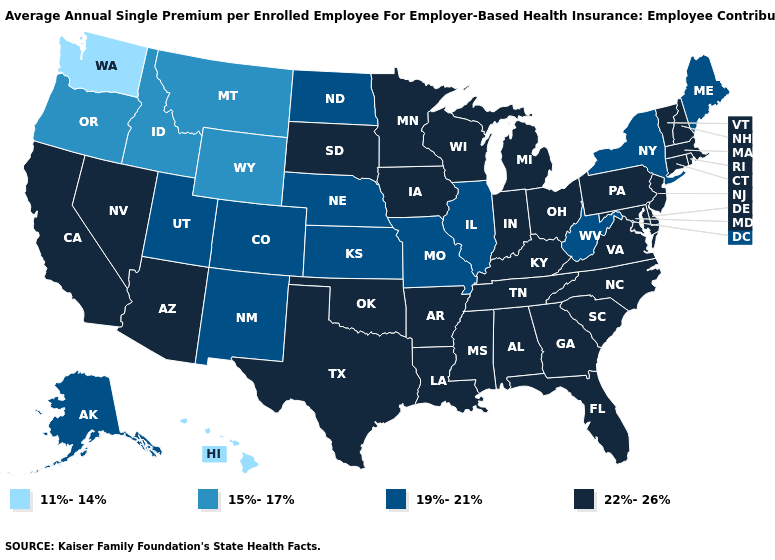What is the highest value in the USA?
Short answer required. 22%-26%. Name the states that have a value in the range 22%-26%?
Write a very short answer. Alabama, Arizona, Arkansas, California, Connecticut, Delaware, Florida, Georgia, Indiana, Iowa, Kentucky, Louisiana, Maryland, Massachusetts, Michigan, Minnesota, Mississippi, Nevada, New Hampshire, New Jersey, North Carolina, Ohio, Oklahoma, Pennsylvania, Rhode Island, South Carolina, South Dakota, Tennessee, Texas, Vermont, Virginia, Wisconsin. What is the value of New Hampshire?
Short answer required. 22%-26%. What is the lowest value in the USA?
Write a very short answer. 11%-14%. What is the highest value in states that border Washington?
Write a very short answer. 15%-17%. Name the states that have a value in the range 22%-26%?
Concise answer only. Alabama, Arizona, Arkansas, California, Connecticut, Delaware, Florida, Georgia, Indiana, Iowa, Kentucky, Louisiana, Maryland, Massachusetts, Michigan, Minnesota, Mississippi, Nevada, New Hampshire, New Jersey, North Carolina, Ohio, Oklahoma, Pennsylvania, Rhode Island, South Carolina, South Dakota, Tennessee, Texas, Vermont, Virginia, Wisconsin. Name the states that have a value in the range 19%-21%?
Be succinct. Alaska, Colorado, Illinois, Kansas, Maine, Missouri, Nebraska, New Mexico, New York, North Dakota, Utah, West Virginia. Among the states that border California , which have the highest value?
Keep it brief. Arizona, Nevada. What is the value of Oregon?
Short answer required. 15%-17%. Does the map have missing data?
Quick response, please. No. Name the states that have a value in the range 19%-21%?
Quick response, please. Alaska, Colorado, Illinois, Kansas, Maine, Missouri, Nebraska, New Mexico, New York, North Dakota, Utah, West Virginia. Does Oregon have the same value as California?
Concise answer only. No. Which states have the lowest value in the USA?
Answer briefly. Hawaii, Washington. Does the map have missing data?
Write a very short answer. No. 